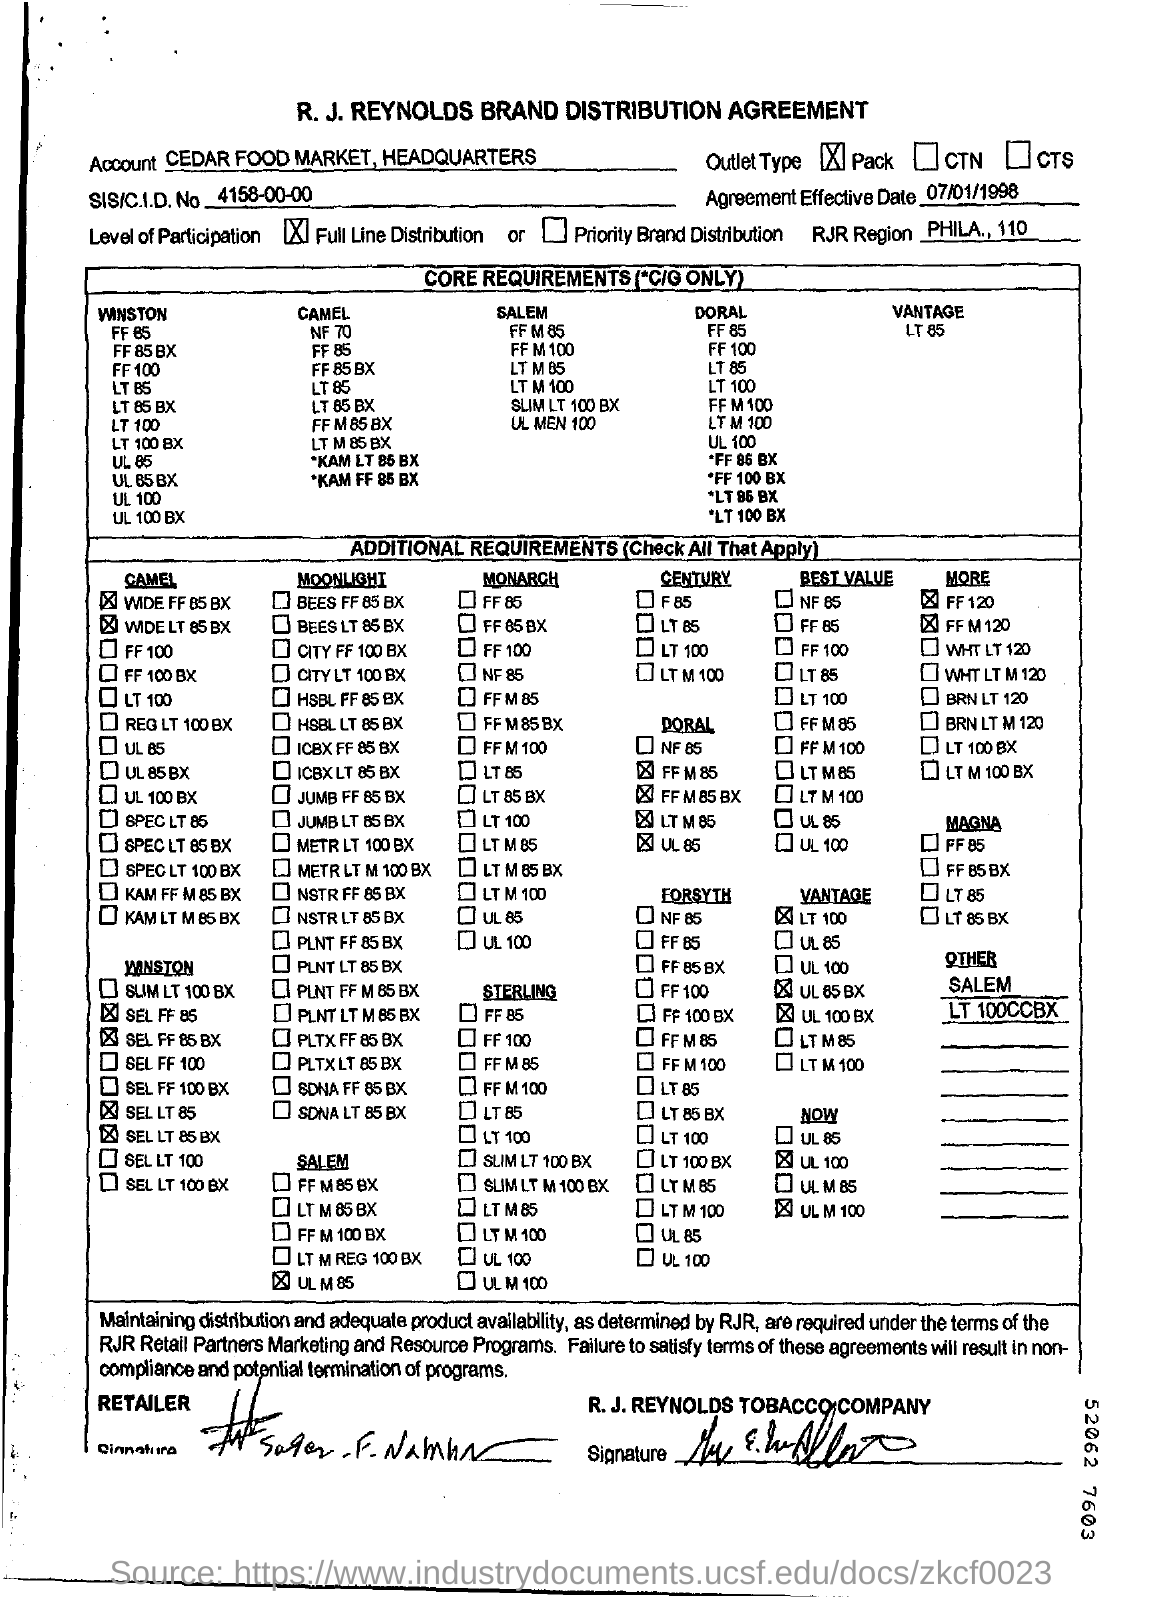Identify some key points in this picture. The account name mentioned is CEDAR FOOD MARKET, HEADQUARTERS. The SIS/CID number is 4158-00-00. Level of participation refers to the degree to which a person is involved in a particular activity, with full line distribution meaning that all aspects of the activity are equally considered and considered in the process. The effective date of the agreement is July 1, 1998. The document in question is titled "R. J. REYNOLDS BRAND DISTRIBUTION AGREEMENT. 